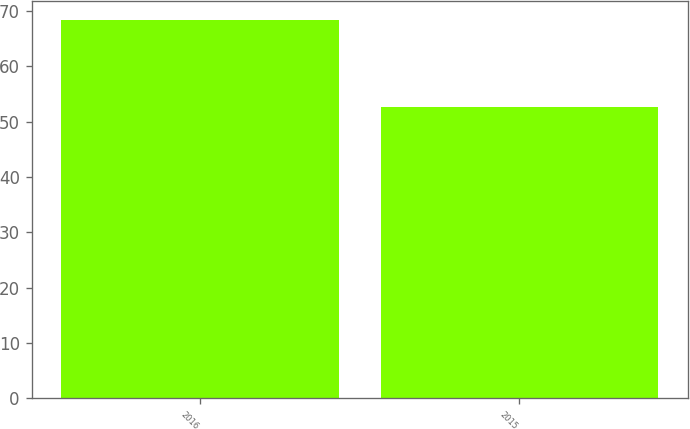Convert chart. <chart><loc_0><loc_0><loc_500><loc_500><bar_chart><fcel>2016<fcel>2015<nl><fcel>68.42<fcel>52.73<nl></chart> 